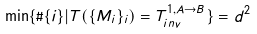<formula> <loc_0><loc_0><loc_500><loc_500>\min \{ \# \{ i \} | T ( \{ M _ { i } \} _ { i } ) = T _ { i n v } ^ { 1 , A \to B } \} = d ^ { 2 }</formula> 